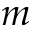<formula> <loc_0><loc_0><loc_500><loc_500>m</formula> 